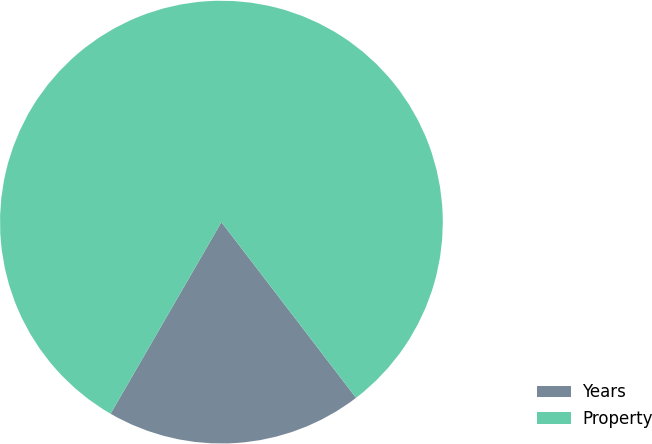Convert chart. <chart><loc_0><loc_0><loc_500><loc_500><pie_chart><fcel>Years<fcel>Property<nl><fcel>18.75%<fcel>81.25%<nl></chart> 